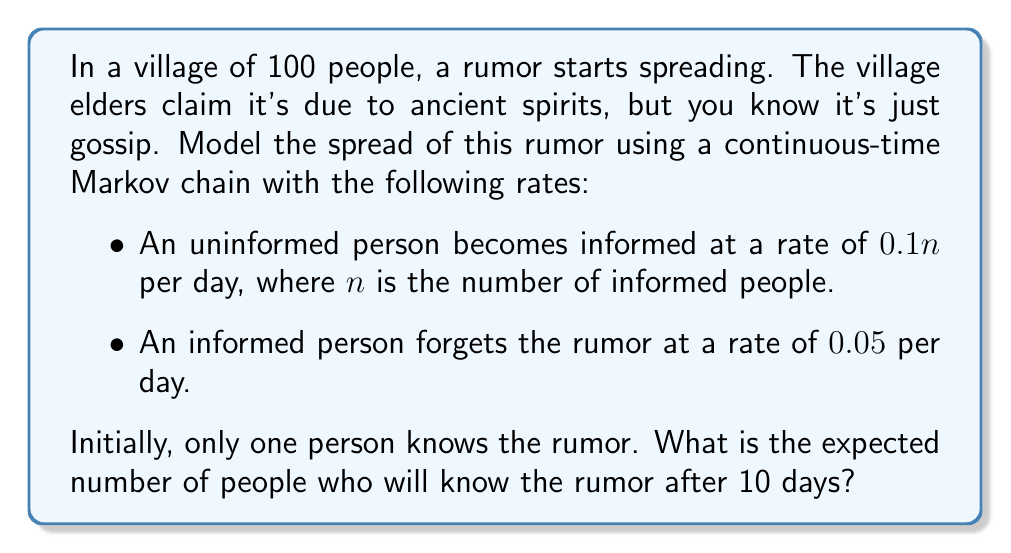What is the answer to this math problem? Let's approach this step-by-step:

1) We can model this as a birth-death process where $X(t)$ represents the number of informed people at time $t$.

2) The transition rates are:
   $q_{n,n+1} = 0.1n(100-n)$ for $n = 0,1,\ldots,99$
   $q_{n,n-1} = 0.05n$ for $n = 1,2,\ldots,100$

3) The differential equation for the expected number of informed people $E[X(t)]$ is:

   $$\frac{d}{dt}E[X(t)] = 0.1E[X(t)](100-E[X(t)]) - 0.05E[X(t)]$$

4) This is a logistic differential equation. The solution is:

   $$E[X(t)] = \frac{100K}{K + (100-K)e^{-0.1Kt}}$$

   where $K = 1 - \frac{0.05}{10} = 0.995$

5) Initially, $X(0) = 1$, so:

   $$E[X(10)] = \frac{100 \cdot 0.995}{0.995 + (100-0.995)e^{-0.1 \cdot 0.995 \cdot 10}}$$

6) Calculating this:

   $$E[X(10)] \approx 64.76$$
Answer: 64.76 people 